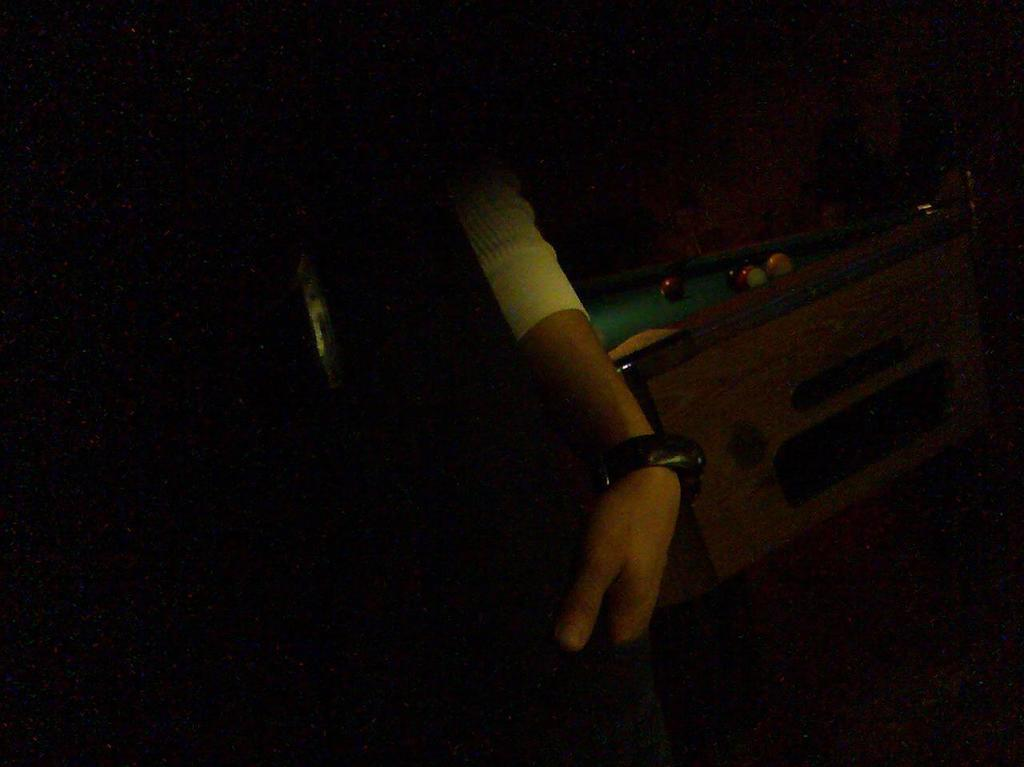What is being held by the person's hand in the image? There is a person's hand with a watch in the image. What type of table is visible in the image? There is a billiard table in the image. What is on top of the billiard table? There are balls on the billiard table. What type of collar is visible on the billiard balls in the image? There are no collars present on the billiard balls in the image. How does the person blow the balls into the pockets in the image? The image does not show the person playing billiards or blowing the balls into the pockets. 